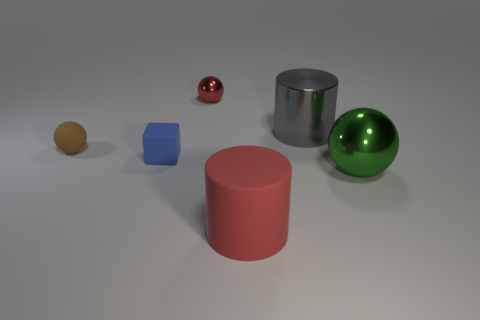Can you describe the shapes of objects I can see in the image? Certainly! In the image, you can see various geometric shapes including a sphere, a cylinder, and a cube. The sphere has a perfectly round shape, the cylinder has a circular base with a height extending from it, and the cube is a six-sided figure with all sides equal in size. 